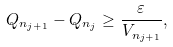Convert formula to latex. <formula><loc_0><loc_0><loc_500><loc_500>Q _ { n _ { j + 1 } } - Q _ { n _ { j } } \geq \frac { \varepsilon } { V _ { n _ { j + 1 } } } ,</formula> 